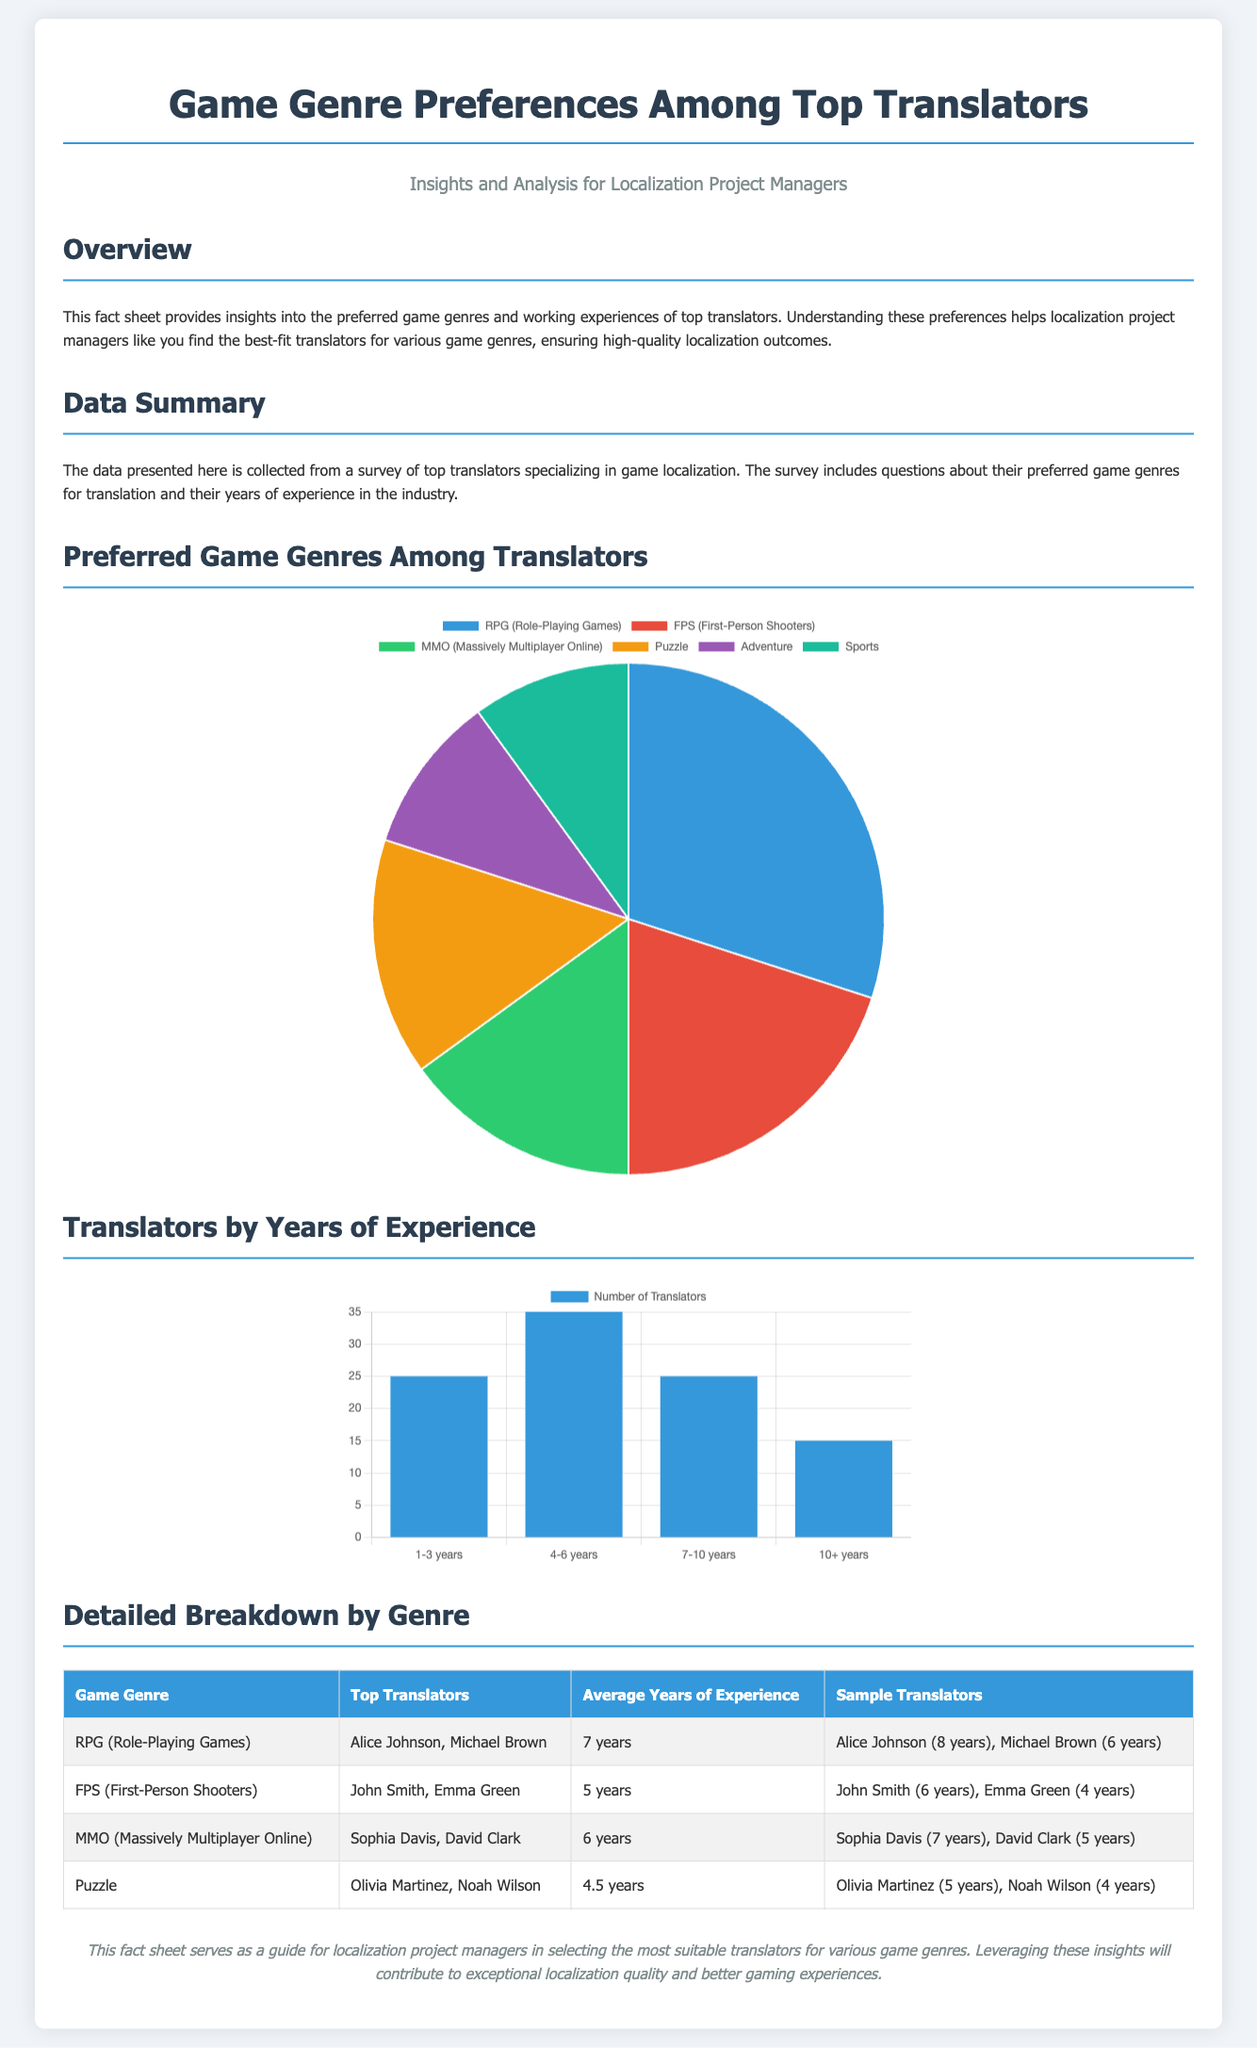What is the preferred game genre with the highest percentage? The genre with the highest percentage from the pie chart is RPG (Role-Playing Games) with 30%.
Answer: RPG (Role-Playing Games) Who are the top translators for FPS (First-Person Shooters)? The document lists John Smith and Emma Green as top translators for FPS.
Answer: John Smith, Emma Green How many genres are represented in the document? There are six genres presented in the pie chart.
Answer: Six What is the average years of experience for translators specializing in Puzzle games? The average years of experience for translators in Puzzle games is 4.5 years.
Answer: 4.5 years What percentage of translators have 1-3 years of experience? 25% of translators fall into the 1-3 years of experience category.
Answer: 25% Which genre has the second highest number of years of average experience? The genre with the second highest average years of experience is MMO with 6 years.
Answer: MMO How many translators are there with 10+ years of experience? The document indicates that there are 15 translators with 10+ years of experience.
Answer: 15 What color is used to represent RPG in the pie chart? The color used for RPG (Role-Playing Games) in the pie chart is blue.
Answer: Blue 